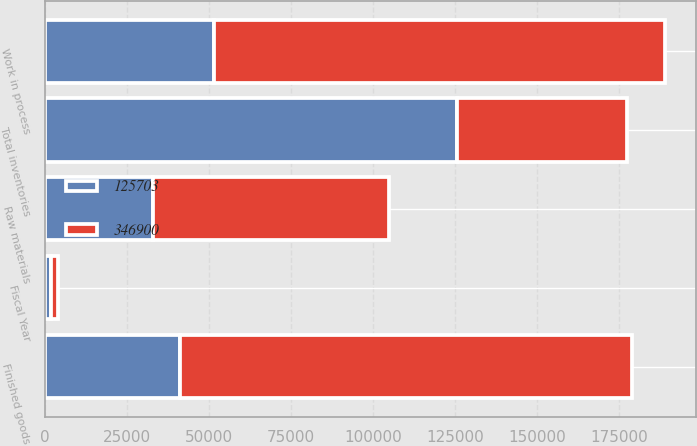Convert chart. <chart><loc_0><loc_0><loc_500><loc_500><stacked_bar_chart><ecel><fcel>Fiscal Year<fcel>Raw materials<fcel>Work in process<fcel>Finished goods<fcel>Total inventories<nl><fcel>346900<fcel>2015<fcel>71863<fcel>137306<fcel>137731<fcel>51544<nl><fcel>125703<fcel>2014<fcel>32927<fcel>51544<fcel>41232<fcel>125703<nl></chart> 